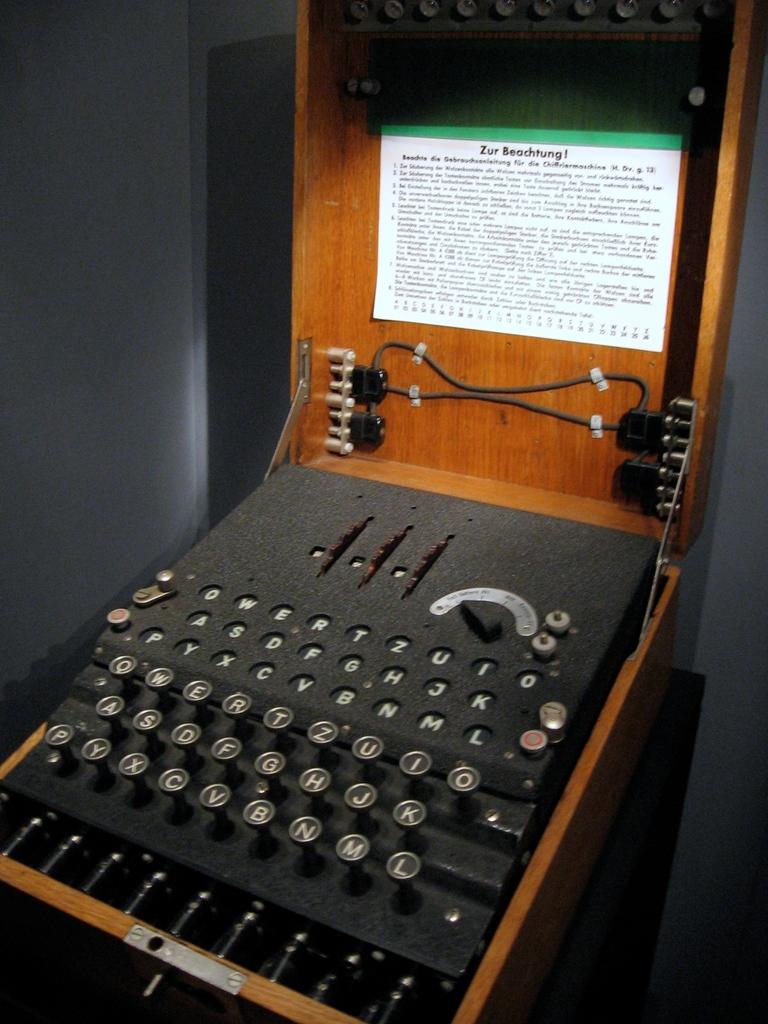What is the first letter on the keyboard?
Give a very brief answer. Q. What is the letter on the bottom left most key?
Give a very brief answer. P. 